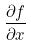Convert formula to latex. <formula><loc_0><loc_0><loc_500><loc_500>\frac { \partial f } { \partial x }</formula> 